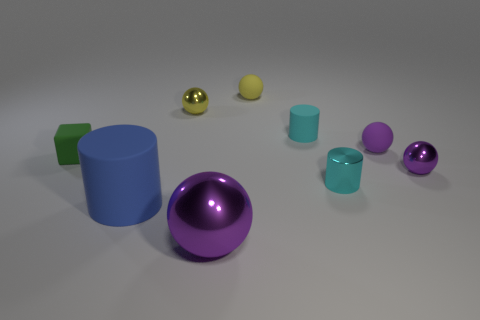Subtract all purple matte balls. How many balls are left? 4 Subtract all balls. How many objects are left? 4 Subtract all blue cylinders. How many cylinders are left? 2 Subtract all brown cubes. Subtract all blue cylinders. How many cubes are left? 1 Subtract all gray blocks. How many red cylinders are left? 0 Subtract all metal things. Subtract all tiny cyan metal things. How many objects are left? 4 Add 7 tiny green rubber objects. How many tiny green rubber objects are left? 8 Add 4 rubber objects. How many rubber objects exist? 9 Subtract 0 red cubes. How many objects are left? 9 